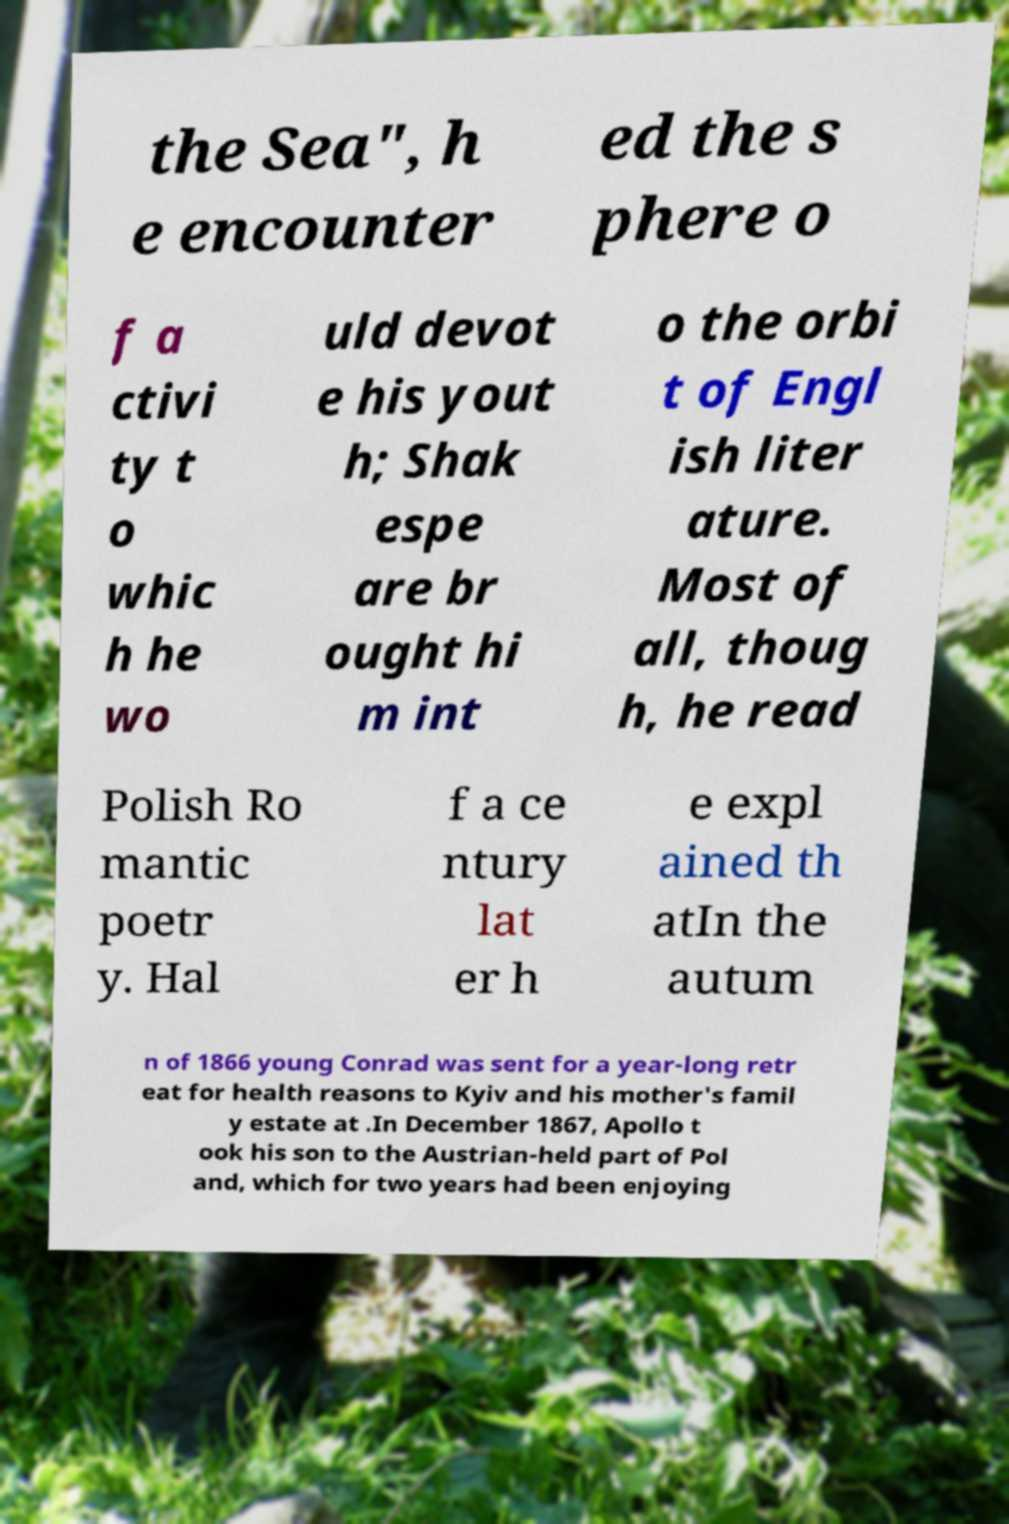Could you extract and type out the text from this image? the Sea", h e encounter ed the s phere o f a ctivi ty t o whic h he wo uld devot e his yout h; Shak espe are br ought hi m int o the orbi t of Engl ish liter ature. Most of all, thoug h, he read Polish Ro mantic poetr y. Hal f a ce ntury lat er h e expl ained th atIn the autum n of 1866 young Conrad was sent for a year-long retr eat for health reasons to Kyiv and his mother's famil y estate at .In December 1867, Apollo t ook his son to the Austrian-held part of Pol and, which for two years had been enjoying 